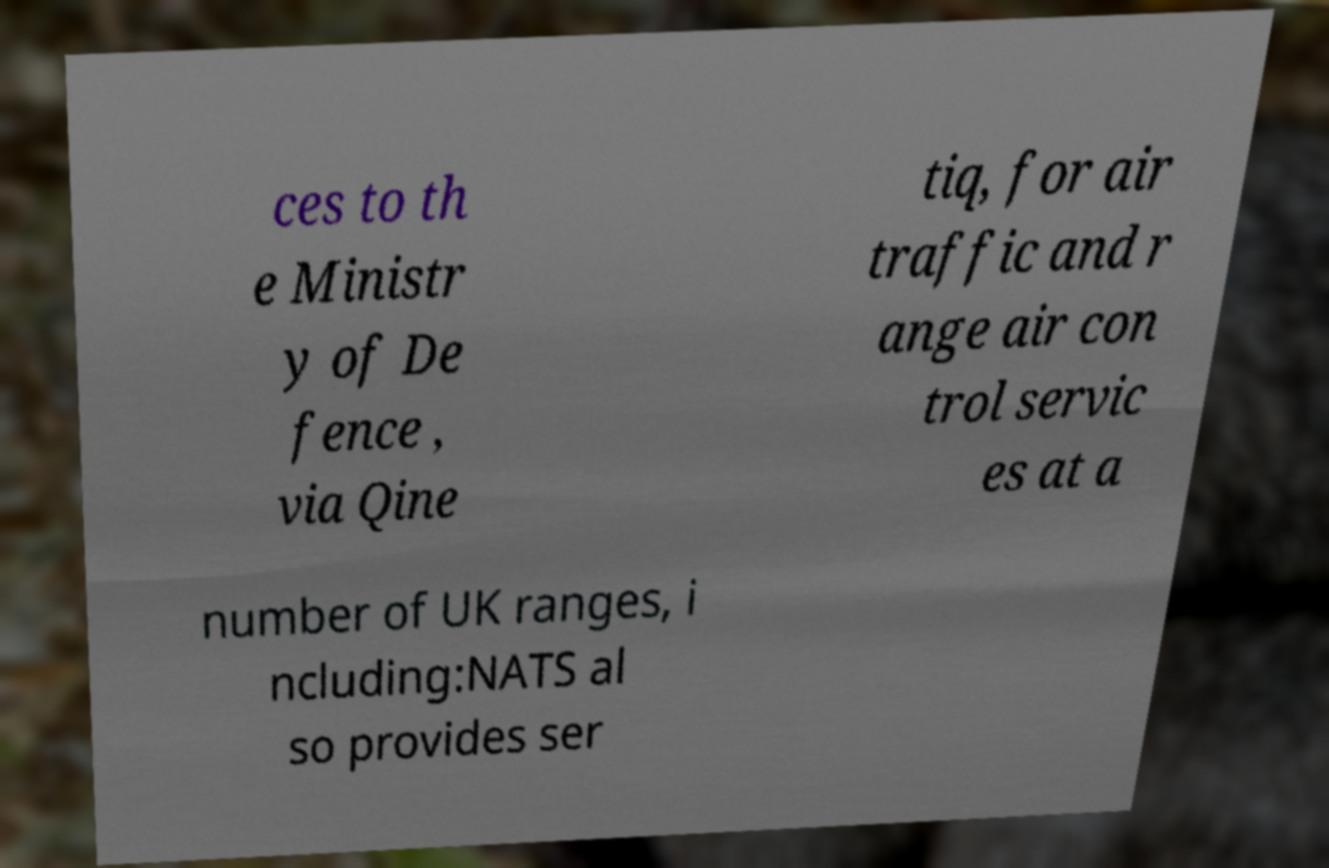I need the written content from this picture converted into text. Can you do that? ces to th e Ministr y of De fence , via Qine tiq, for air traffic and r ange air con trol servic es at a number of UK ranges, i ncluding:NATS al so provides ser 